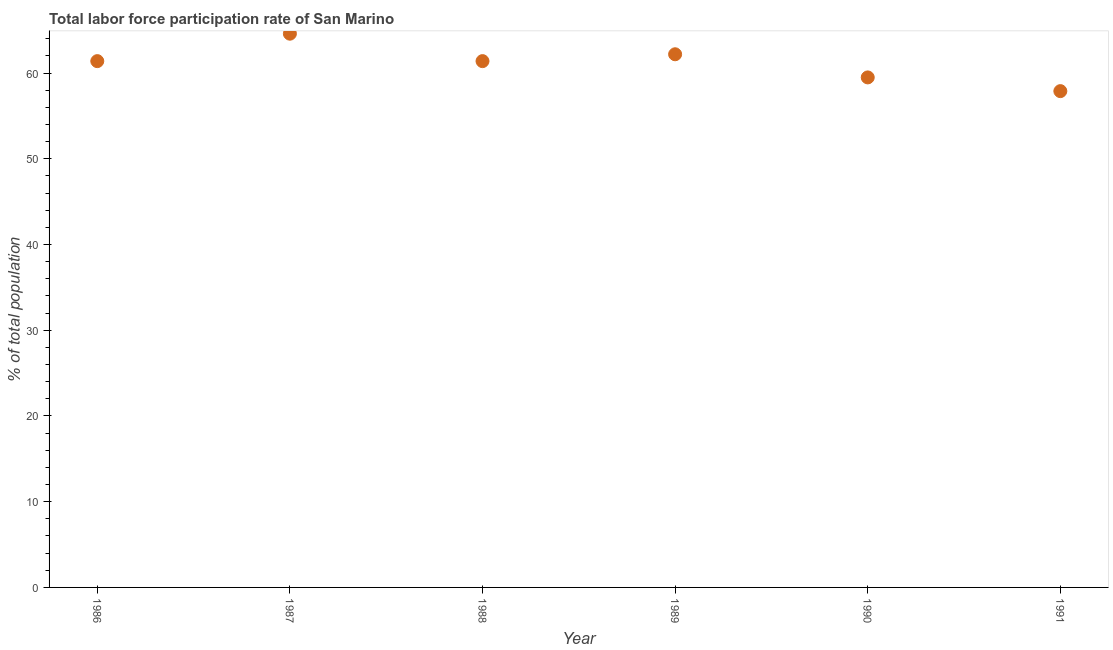What is the total labor force participation rate in 1990?
Ensure brevity in your answer.  59.5. Across all years, what is the maximum total labor force participation rate?
Make the answer very short. 64.6. Across all years, what is the minimum total labor force participation rate?
Give a very brief answer. 57.9. In which year was the total labor force participation rate minimum?
Ensure brevity in your answer.  1991. What is the sum of the total labor force participation rate?
Offer a terse response. 367. What is the difference between the total labor force participation rate in 1986 and 1991?
Keep it short and to the point. 3.5. What is the average total labor force participation rate per year?
Your answer should be very brief. 61.17. What is the median total labor force participation rate?
Your answer should be very brief. 61.4. What is the ratio of the total labor force participation rate in 1986 to that in 1987?
Provide a succinct answer. 0.95. Is the difference between the total labor force participation rate in 1986 and 1989 greater than the difference between any two years?
Your response must be concise. No. What is the difference between the highest and the second highest total labor force participation rate?
Your answer should be very brief. 2.4. Is the sum of the total labor force participation rate in 1986 and 1989 greater than the maximum total labor force participation rate across all years?
Give a very brief answer. Yes. What is the difference between the highest and the lowest total labor force participation rate?
Make the answer very short. 6.7. In how many years, is the total labor force participation rate greater than the average total labor force participation rate taken over all years?
Offer a very short reply. 4. Does the total labor force participation rate monotonically increase over the years?
Give a very brief answer. No. How many dotlines are there?
Offer a terse response. 1. How many years are there in the graph?
Offer a very short reply. 6. What is the difference between two consecutive major ticks on the Y-axis?
Provide a succinct answer. 10. Does the graph contain any zero values?
Provide a succinct answer. No. What is the title of the graph?
Your response must be concise. Total labor force participation rate of San Marino. What is the label or title of the Y-axis?
Provide a succinct answer. % of total population. What is the % of total population in 1986?
Keep it short and to the point. 61.4. What is the % of total population in 1987?
Your answer should be compact. 64.6. What is the % of total population in 1988?
Your answer should be very brief. 61.4. What is the % of total population in 1989?
Make the answer very short. 62.2. What is the % of total population in 1990?
Give a very brief answer. 59.5. What is the % of total population in 1991?
Make the answer very short. 57.9. What is the difference between the % of total population in 1986 and 1989?
Your answer should be very brief. -0.8. What is the difference between the % of total population in 1986 and 1990?
Ensure brevity in your answer.  1.9. What is the difference between the % of total population in 1987 and 1989?
Give a very brief answer. 2.4. What is the difference between the % of total population in 1987 and 1990?
Offer a terse response. 5.1. What is the difference between the % of total population in 1988 and 1989?
Give a very brief answer. -0.8. What is the difference between the % of total population in 1989 and 1991?
Provide a succinct answer. 4.3. What is the difference between the % of total population in 1990 and 1991?
Offer a terse response. 1.6. What is the ratio of the % of total population in 1986 to that in 1987?
Offer a very short reply. 0.95. What is the ratio of the % of total population in 1986 to that in 1988?
Ensure brevity in your answer.  1. What is the ratio of the % of total population in 1986 to that in 1989?
Provide a short and direct response. 0.99. What is the ratio of the % of total population in 1986 to that in 1990?
Ensure brevity in your answer.  1.03. What is the ratio of the % of total population in 1986 to that in 1991?
Offer a terse response. 1.06. What is the ratio of the % of total population in 1987 to that in 1988?
Make the answer very short. 1.05. What is the ratio of the % of total population in 1987 to that in 1989?
Your answer should be very brief. 1.04. What is the ratio of the % of total population in 1987 to that in 1990?
Ensure brevity in your answer.  1.09. What is the ratio of the % of total population in 1987 to that in 1991?
Ensure brevity in your answer.  1.12. What is the ratio of the % of total population in 1988 to that in 1989?
Ensure brevity in your answer.  0.99. What is the ratio of the % of total population in 1988 to that in 1990?
Make the answer very short. 1.03. What is the ratio of the % of total population in 1988 to that in 1991?
Ensure brevity in your answer.  1.06. What is the ratio of the % of total population in 1989 to that in 1990?
Keep it short and to the point. 1.04. What is the ratio of the % of total population in 1989 to that in 1991?
Your response must be concise. 1.07. What is the ratio of the % of total population in 1990 to that in 1991?
Ensure brevity in your answer.  1.03. 